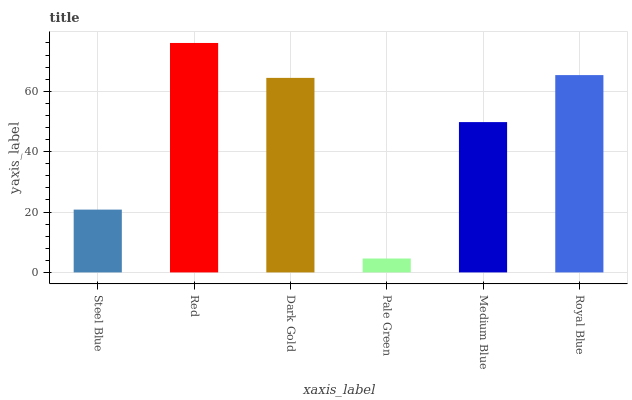Is Pale Green the minimum?
Answer yes or no. Yes. Is Red the maximum?
Answer yes or no. Yes. Is Dark Gold the minimum?
Answer yes or no. No. Is Dark Gold the maximum?
Answer yes or no. No. Is Red greater than Dark Gold?
Answer yes or no. Yes. Is Dark Gold less than Red?
Answer yes or no. Yes. Is Dark Gold greater than Red?
Answer yes or no. No. Is Red less than Dark Gold?
Answer yes or no. No. Is Dark Gold the high median?
Answer yes or no. Yes. Is Medium Blue the low median?
Answer yes or no. Yes. Is Pale Green the high median?
Answer yes or no. No. Is Pale Green the low median?
Answer yes or no. No. 